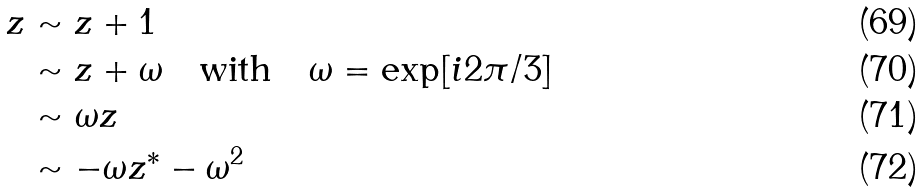<formula> <loc_0><loc_0><loc_500><loc_500>z & \sim z + 1 \\ & \sim z + \omega \quad \text {with} \quad \omega = \exp [ i 2 \pi / 3 ] \\ & \sim \omega z \\ & \sim - \omega z ^ { * } - \omega ^ { 2 }</formula> 